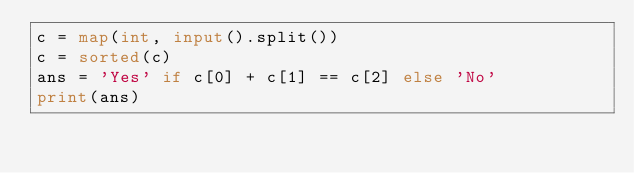<code> <loc_0><loc_0><loc_500><loc_500><_Python_>c = map(int, input().split())
c = sorted(c)
ans = 'Yes' if c[0] + c[1] == c[2] else 'No'
print(ans)
</code> 